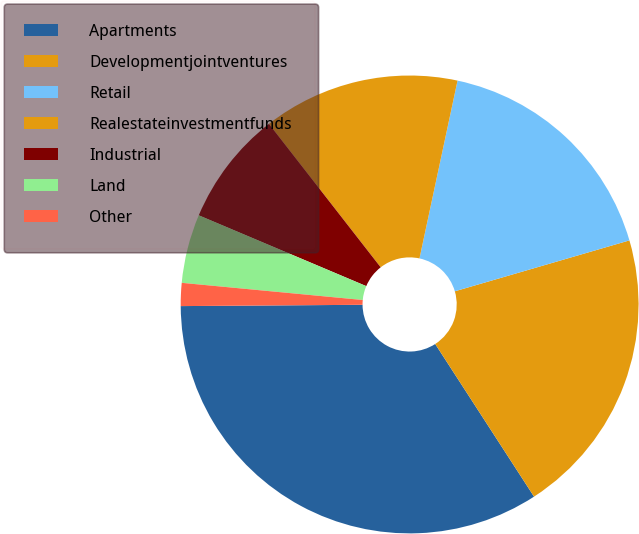<chart> <loc_0><loc_0><loc_500><loc_500><pie_chart><fcel>Apartments<fcel>Developmentjointventures<fcel>Retail<fcel>Realestateinvestmentfunds<fcel>Industrial<fcel>Land<fcel>Other<nl><fcel>34.03%<fcel>20.37%<fcel>17.13%<fcel>13.89%<fcel>8.1%<fcel>4.86%<fcel>1.62%<nl></chart> 